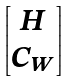Convert formula to latex. <formula><loc_0><loc_0><loc_500><loc_500>\begin{bmatrix} H \\ C _ { W } \\ \end{bmatrix}</formula> 